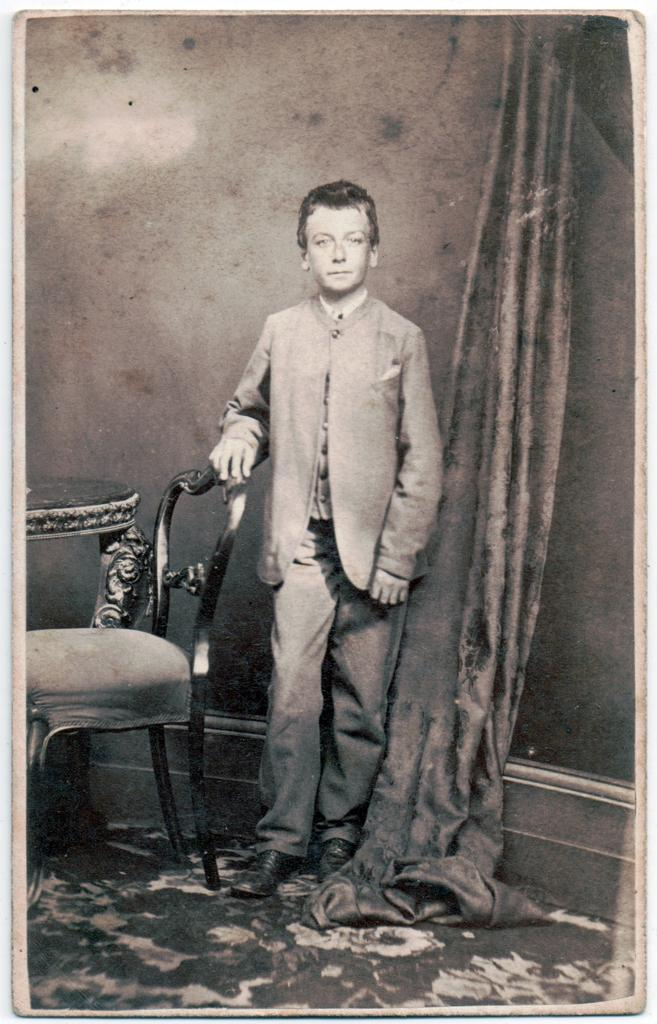What is the main subject of the image? There is a person in the image. What is the person doing in the image? The person is standing beside a table. What object is the person holding in the image? The person is holding a chair. What time of day is it in the image, and is the person swimming? The time of day is not mentioned in the image, and there is no indication that the person is swimming. 